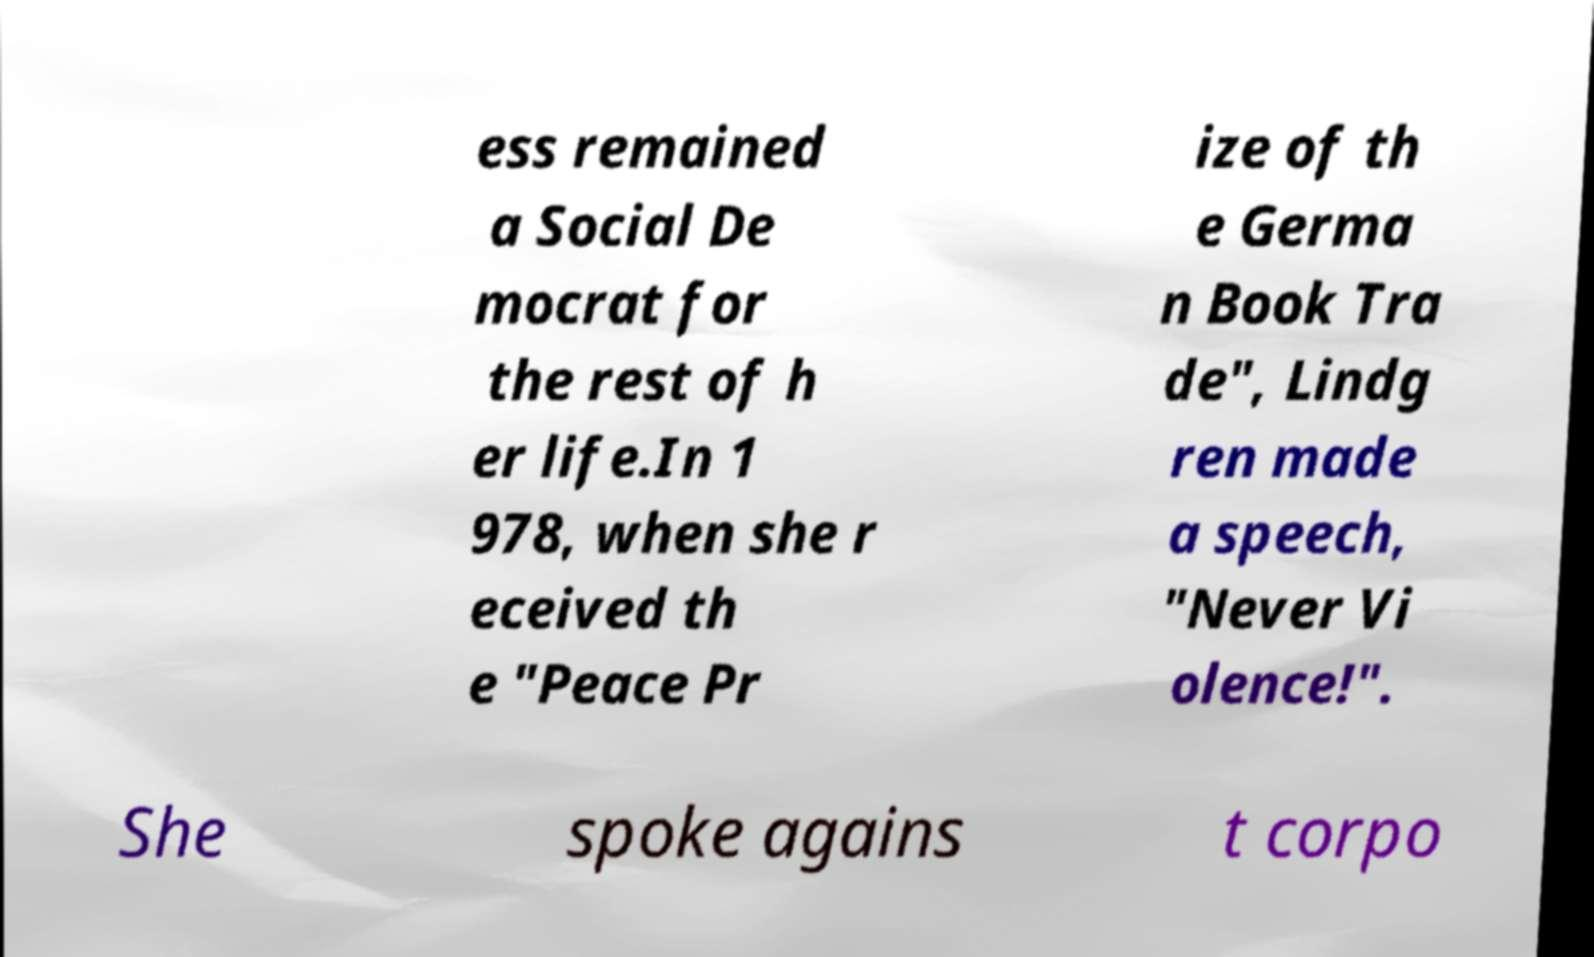For documentation purposes, I need the text within this image transcribed. Could you provide that? ess remained a Social De mocrat for the rest of h er life.In 1 978, when she r eceived th e "Peace Pr ize of th e Germa n Book Tra de", Lindg ren made a speech, "Never Vi olence!". She spoke agains t corpo 